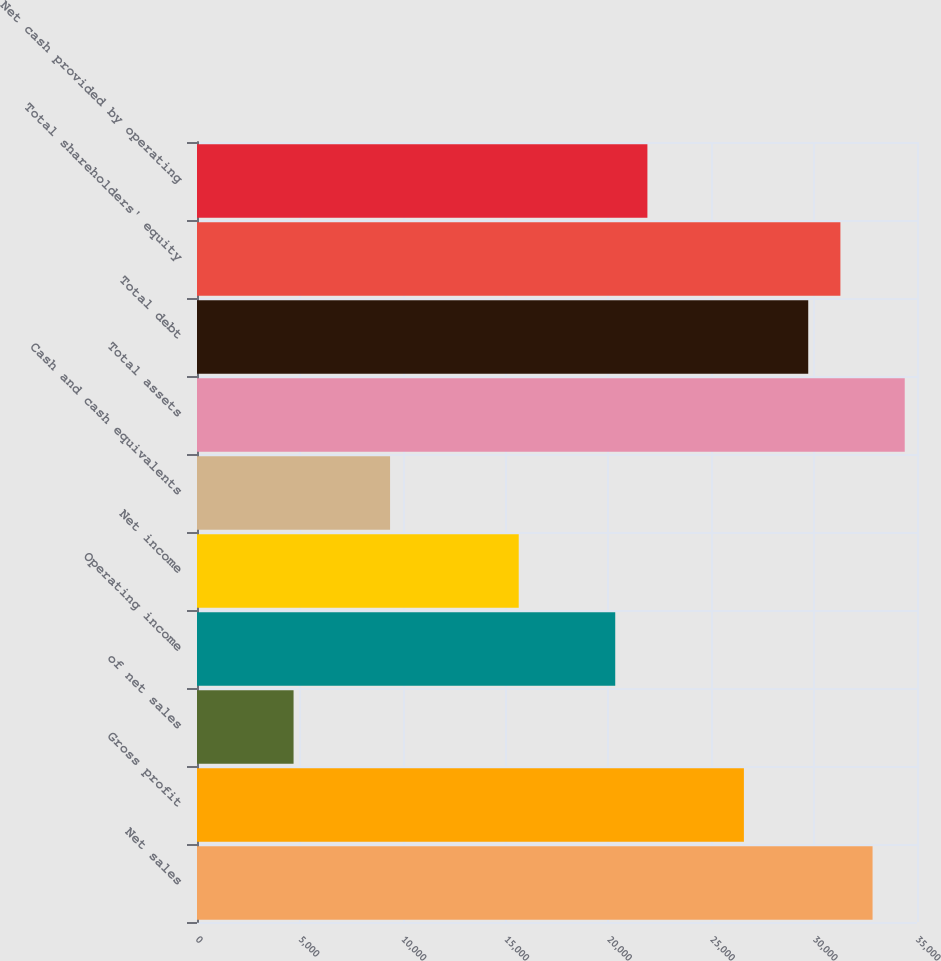Convert chart to OTSL. <chart><loc_0><loc_0><loc_500><loc_500><bar_chart><fcel>Net sales<fcel>Gross profit<fcel>of net sales<fcel>Operating income<fcel>Net income<fcel>Cash and cash equivalents<fcel>Total assets<fcel>Total debt<fcel>Total shareholders' equity<fcel>Net cash provided by operating<nl><fcel>32840.1<fcel>26585.4<fcel>4694.01<fcel>20330.7<fcel>15639.7<fcel>9385.02<fcel>34403.7<fcel>29712.7<fcel>31276.4<fcel>21894.4<nl></chart> 